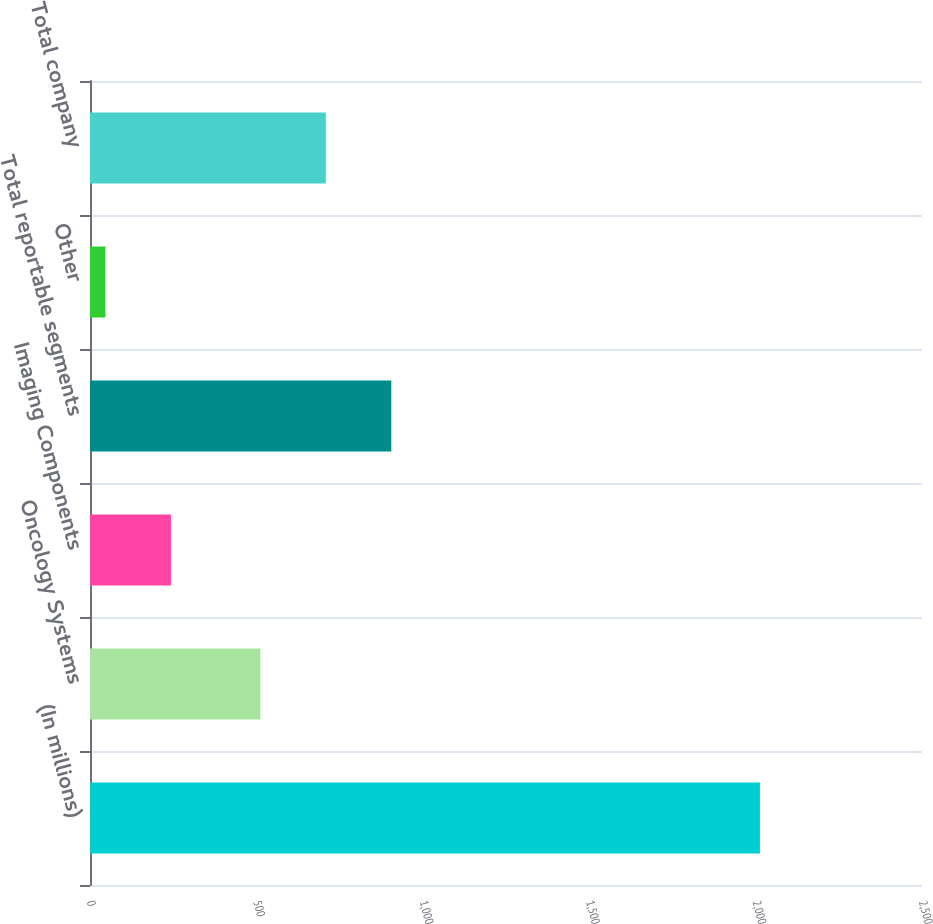Convert chart. <chart><loc_0><loc_0><loc_500><loc_500><bar_chart><fcel>(In millions)<fcel>Oncology Systems<fcel>Imaging Components<fcel>Total reportable segments<fcel>Other<fcel>Total company<nl><fcel>2013<fcel>512<fcel>243.06<fcel>905.32<fcel>46.4<fcel>708.66<nl></chart> 